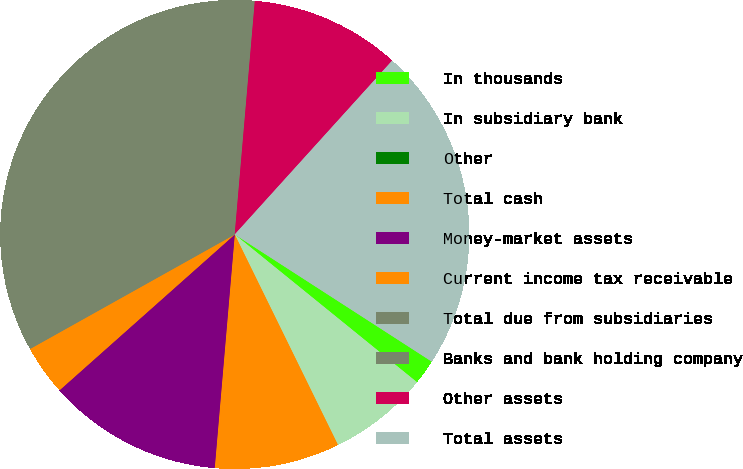<chart> <loc_0><loc_0><loc_500><loc_500><pie_chart><fcel>In thousands<fcel>In subsidiary bank<fcel>Other<fcel>Total cash<fcel>Money-market assets<fcel>Current income tax receivable<fcel>Total due from subsidiaries<fcel>Banks and bank holding company<fcel>Other assets<fcel>Total assets<nl><fcel>1.72%<fcel>6.9%<fcel>0.0%<fcel>8.62%<fcel>12.07%<fcel>3.45%<fcel>13.79%<fcel>20.69%<fcel>10.34%<fcel>22.41%<nl></chart> 